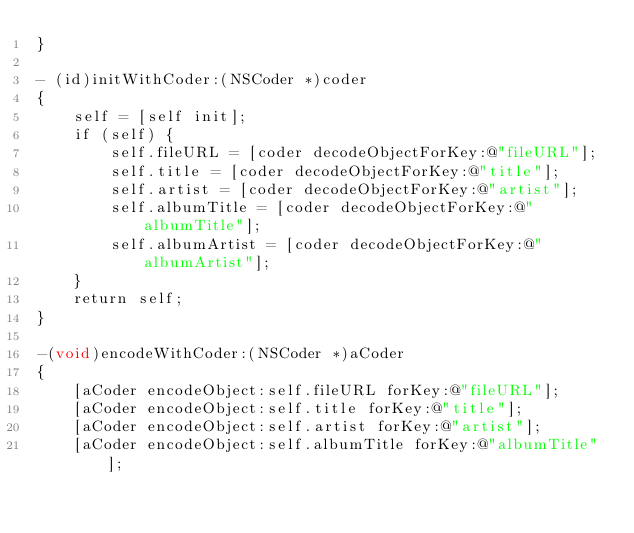Convert code to text. <code><loc_0><loc_0><loc_500><loc_500><_ObjectiveC_>}

- (id)initWithCoder:(NSCoder *)coder
{
    self = [self init];
    if (self) {
        self.fileURL = [coder decodeObjectForKey:@"fileURL"];
        self.title = [coder decodeObjectForKey:@"title"];
        self.artist = [coder decodeObjectForKey:@"artist"];
        self.albumTitle = [coder decodeObjectForKey:@"albumTitle"];
        self.albumArtist = [coder decodeObjectForKey:@"albumArtist"];
    }
    return self;
}

-(void)encodeWithCoder:(NSCoder *)aCoder
{
    [aCoder encodeObject:self.fileURL forKey:@"fileURL"];
    [aCoder encodeObject:self.title forKey:@"title"];
    [aCoder encodeObject:self.artist forKey:@"artist"];
    [aCoder encodeObject:self.albumTitle forKey:@"albumTitle"];</code> 